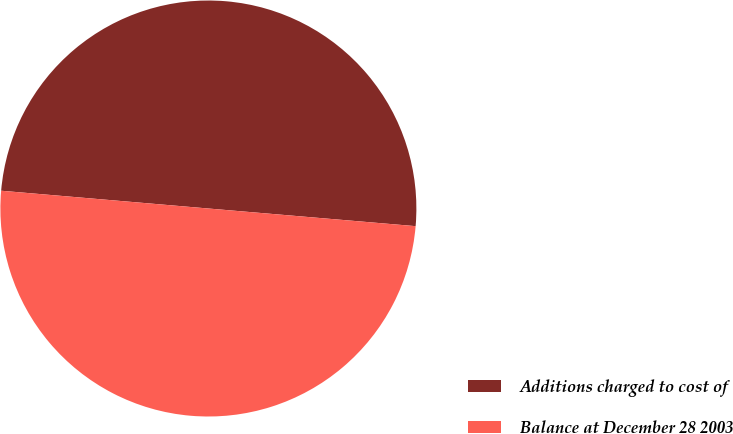Convert chart to OTSL. <chart><loc_0><loc_0><loc_500><loc_500><pie_chart><fcel>Additions charged to cost of<fcel>Balance at December 28 2003<nl><fcel>49.99%<fcel>50.01%<nl></chart> 